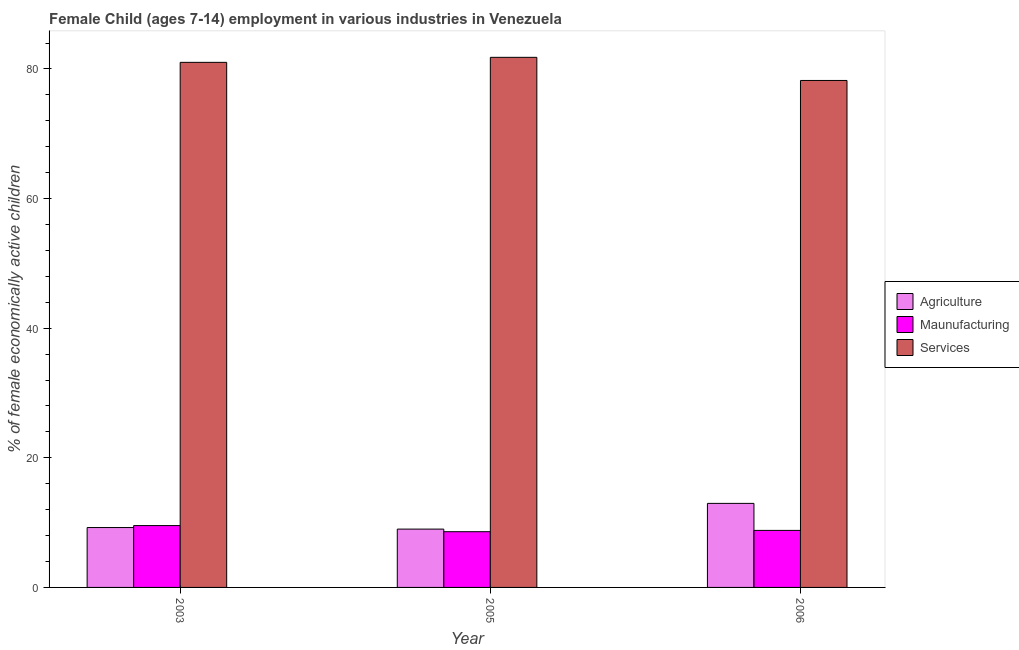Are the number of bars on each tick of the X-axis equal?
Ensure brevity in your answer.  Yes. How many bars are there on the 3rd tick from the right?
Offer a terse response. 3. What is the label of the 3rd group of bars from the left?
Keep it short and to the point. 2006. In how many cases, is the number of bars for a given year not equal to the number of legend labels?
Offer a very short reply. 0. Across all years, what is the maximum percentage of economically active children in services?
Give a very brief answer. 81.8. In which year was the percentage of economically active children in services maximum?
Provide a succinct answer. 2005. What is the total percentage of economically active children in manufacturing in the graph?
Ensure brevity in your answer.  26.94. What is the difference between the percentage of economically active children in services in 2003 and that in 2005?
Your response must be concise. -0.78. What is the difference between the percentage of economically active children in agriculture in 2003 and the percentage of economically active children in manufacturing in 2005?
Your response must be concise. 0.24. What is the average percentage of economically active children in agriculture per year?
Make the answer very short. 10.4. In how many years, is the percentage of economically active children in manufacturing greater than 64 %?
Your response must be concise. 0. What is the ratio of the percentage of economically active children in agriculture in 2003 to that in 2005?
Offer a terse response. 1.03. Is the percentage of economically active children in agriculture in 2005 less than that in 2006?
Offer a very short reply. Yes. What is the difference between the highest and the second highest percentage of economically active children in agriculture?
Your response must be concise. 3.73. What is the difference between the highest and the lowest percentage of economically active children in manufacturing?
Your answer should be compact. 0.94. Is the sum of the percentage of economically active children in agriculture in 2003 and 2006 greater than the maximum percentage of economically active children in manufacturing across all years?
Offer a very short reply. Yes. What does the 3rd bar from the left in 2005 represents?
Offer a terse response. Services. What does the 2nd bar from the right in 2005 represents?
Offer a terse response. Maunufacturing. Is it the case that in every year, the sum of the percentage of economically active children in agriculture and percentage of economically active children in manufacturing is greater than the percentage of economically active children in services?
Your answer should be compact. No. Are all the bars in the graph horizontal?
Provide a short and direct response. No. How many years are there in the graph?
Give a very brief answer. 3. Are the values on the major ticks of Y-axis written in scientific E-notation?
Your response must be concise. No. Where does the legend appear in the graph?
Your answer should be compact. Center right. How many legend labels are there?
Offer a very short reply. 3. What is the title of the graph?
Your answer should be very brief. Female Child (ages 7-14) employment in various industries in Venezuela. What is the label or title of the Y-axis?
Give a very brief answer. % of female economically active children. What is the % of female economically active children in Agriculture in 2003?
Offer a terse response. 9.24. What is the % of female economically active children in Maunufacturing in 2003?
Your response must be concise. 9.54. What is the % of female economically active children in Services in 2003?
Give a very brief answer. 81.02. What is the % of female economically active children of Services in 2005?
Keep it short and to the point. 81.8. What is the % of female economically active children in Agriculture in 2006?
Ensure brevity in your answer.  12.97. What is the % of female economically active children in Maunufacturing in 2006?
Your response must be concise. 8.8. What is the % of female economically active children of Services in 2006?
Offer a terse response. 78.23. Across all years, what is the maximum % of female economically active children in Agriculture?
Provide a succinct answer. 12.97. Across all years, what is the maximum % of female economically active children of Maunufacturing?
Offer a terse response. 9.54. Across all years, what is the maximum % of female economically active children of Services?
Offer a terse response. 81.8. Across all years, what is the minimum % of female economically active children of Agriculture?
Keep it short and to the point. 9. Across all years, what is the minimum % of female economically active children of Services?
Your response must be concise. 78.23. What is the total % of female economically active children in Agriculture in the graph?
Offer a very short reply. 31.21. What is the total % of female economically active children in Maunufacturing in the graph?
Ensure brevity in your answer.  26.94. What is the total % of female economically active children of Services in the graph?
Give a very brief answer. 241.05. What is the difference between the % of female economically active children in Agriculture in 2003 and that in 2005?
Give a very brief answer. 0.24. What is the difference between the % of female economically active children of Maunufacturing in 2003 and that in 2005?
Offer a terse response. 0.94. What is the difference between the % of female economically active children of Services in 2003 and that in 2005?
Give a very brief answer. -0.78. What is the difference between the % of female economically active children of Agriculture in 2003 and that in 2006?
Provide a succinct answer. -3.73. What is the difference between the % of female economically active children of Maunufacturing in 2003 and that in 2006?
Give a very brief answer. 0.74. What is the difference between the % of female economically active children of Services in 2003 and that in 2006?
Your response must be concise. 2.79. What is the difference between the % of female economically active children of Agriculture in 2005 and that in 2006?
Provide a short and direct response. -3.97. What is the difference between the % of female economically active children of Services in 2005 and that in 2006?
Ensure brevity in your answer.  3.57. What is the difference between the % of female economically active children of Agriculture in 2003 and the % of female economically active children of Maunufacturing in 2005?
Make the answer very short. 0.64. What is the difference between the % of female economically active children in Agriculture in 2003 and the % of female economically active children in Services in 2005?
Your answer should be very brief. -72.56. What is the difference between the % of female economically active children in Maunufacturing in 2003 and the % of female economically active children in Services in 2005?
Make the answer very short. -72.26. What is the difference between the % of female economically active children of Agriculture in 2003 and the % of female economically active children of Maunufacturing in 2006?
Provide a short and direct response. 0.44. What is the difference between the % of female economically active children of Agriculture in 2003 and the % of female economically active children of Services in 2006?
Keep it short and to the point. -68.99. What is the difference between the % of female economically active children of Maunufacturing in 2003 and the % of female economically active children of Services in 2006?
Your answer should be compact. -68.69. What is the difference between the % of female economically active children in Agriculture in 2005 and the % of female economically active children in Maunufacturing in 2006?
Keep it short and to the point. 0.2. What is the difference between the % of female economically active children of Agriculture in 2005 and the % of female economically active children of Services in 2006?
Your response must be concise. -69.23. What is the difference between the % of female economically active children of Maunufacturing in 2005 and the % of female economically active children of Services in 2006?
Offer a terse response. -69.63. What is the average % of female economically active children of Agriculture per year?
Your answer should be compact. 10.4. What is the average % of female economically active children of Maunufacturing per year?
Your response must be concise. 8.98. What is the average % of female economically active children of Services per year?
Offer a very short reply. 80.35. In the year 2003, what is the difference between the % of female economically active children of Agriculture and % of female economically active children of Maunufacturing?
Provide a short and direct response. -0.3. In the year 2003, what is the difference between the % of female economically active children of Agriculture and % of female economically active children of Services?
Offer a terse response. -71.78. In the year 2003, what is the difference between the % of female economically active children of Maunufacturing and % of female economically active children of Services?
Offer a very short reply. -71.48. In the year 2005, what is the difference between the % of female economically active children of Agriculture and % of female economically active children of Services?
Your response must be concise. -72.8. In the year 2005, what is the difference between the % of female economically active children in Maunufacturing and % of female economically active children in Services?
Your answer should be compact. -73.2. In the year 2006, what is the difference between the % of female economically active children in Agriculture and % of female economically active children in Maunufacturing?
Ensure brevity in your answer.  4.17. In the year 2006, what is the difference between the % of female economically active children of Agriculture and % of female economically active children of Services?
Provide a short and direct response. -65.26. In the year 2006, what is the difference between the % of female economically active children of Maunufacturing and % of female economically active children of Services?
Provide a succinct answer. -69.43. What is the ratio of the % of female economically active children of Agriculture in 2003 to that in 2005?
Provide a short and direct response. 1.03. What is the ratio of the % of female economically active children in Maunufacturing in 2003 to that in 2005?
Your answer should be very brief. 1.11. What is the ratio of the % of female economically active children of Agriculture in 2003 to that in 2006?
Make the answer very short. 0.71. What is the ratio of the % of female economically active children in Maunufacturing in 2003 to that in 2006?
Ensure brevity in your answer.  1.08. What is the ratio of the % of female economically active children in Services in 2003 to that in 2006?
Make the answer very short. 1.04. What is the ratio of the % of female economically active children in Agriculture in 2005 to that in 2006?
Provide a succinct answer. 0.69. What is the ratio of the % of female economically active children of Maunufacturing in 2005 to that in 2006?
Provide a succinct answer. 0.98. What is the ratio of the % of female economically active children of Services in 2005 to that in 2006?
Keep it short and to the point. 1.05. What is the difference between the highest and the second highest % of female economically active children of Agriculture?
Provide a short and direct response. 3.73. What is the difference between the highest and the second highest % of female economically active children in Maunufacturing?
Your answer should be very brief. 0.74. What is the difference between the highest and the second highest % of female economically active children of Services?
Offer a very short reply. 0.78. What is the difference between the highest and the lowest % of female economically active children of Agriculture?
Keep it short and to the point. 3.97. What is the difference between the highest and the lowest % of female economically active children in Maunufacturing?
Make the answer very short. 0.94. What is the difference between the highest and the lowest % of female economically active children in Services?
Your answer should be compact. 3.57. 